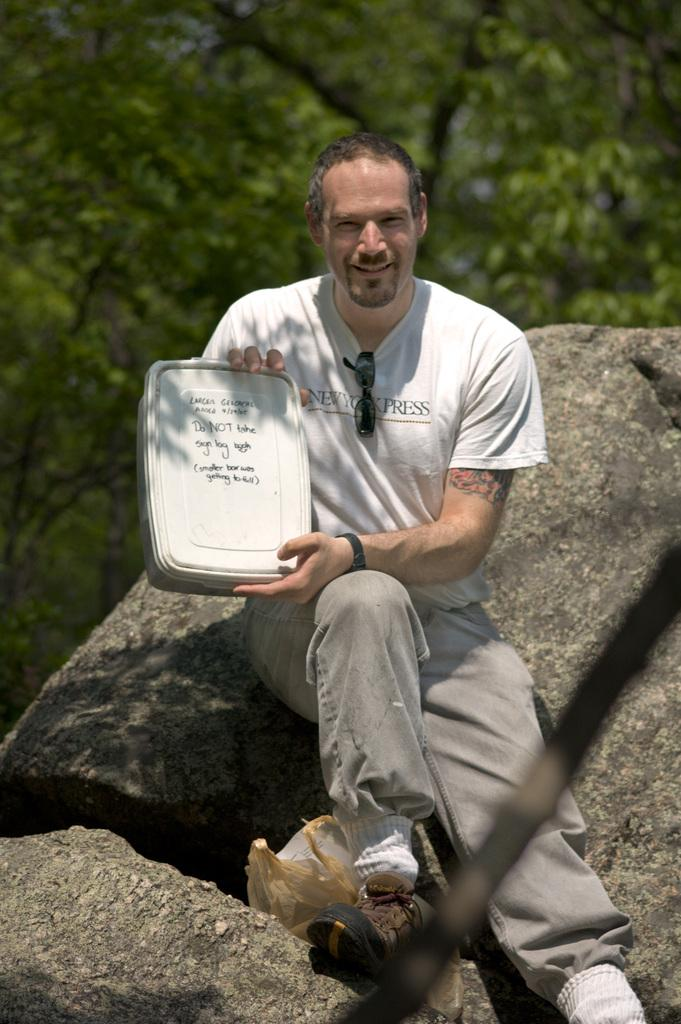Who or what is present in the image? There is a person in the image. What is the person holding in the image? The person is holding a box in the image. What else can be seen in the image besides the person and the box? There are rocks and trees in the image. Can you describe the background of the image? In the background of the image, there are trees. What type of crayon can be seen in the image? There is no crayon present in the image. What furniture is visible in the image? There is no furniture visible in the image. 